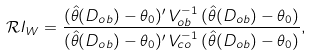Convert formula to latex. <formula><loc_0><loc_0><loc_500><loc_500>\mathcal { R } I _ { W } = \frac { ( \hat { \theta } ( D _ { o b } ) - \theta _ { 0 } ) ^ { \prime } \, V _ { o b } ^ { - 1 } \, ( \hat { \theta } ( D _ { o b } ) - \theta _ { 0 } ) } { ( \hat { \theta } ( D _ { o b } ) - \theta _ { 0 } ) ^ { \prime } \, V _ { c o } ^ { - 1 } \, ( \hat { \theta } ( D _ { o b } ) - \theta _ { 0 } ) } ,</formula> 